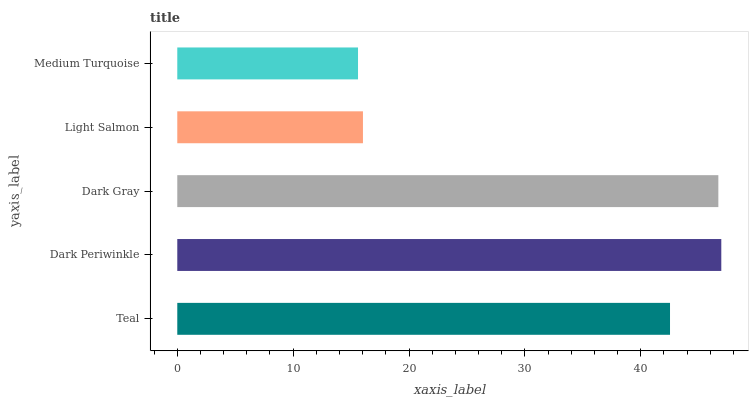Is Medium Turquoise the minimum?
Answer yes or no. Yes. Is Dark Periwinkle the maximum?
Answer yes or no. Yes. Is Dark Gray the minimum?
Answer yes or no. No. Is Dark Gray the maximum?
Answer yes or no. No. Is Dark Periwinkle greater than Dark Gray?
Answer yes or no. Yes. Is Dark Gray less than Dark Periwinkle?
Answer yes or no. Yes. Is Dark Gray greater than Dark Periwinkle?
Answer yes or no. No. Is Dark Periwinkle less than Dark Gray?
Answer yes or no. No. Is Teal the high median?
Answer yes or no. Yes. Is Teal the low median?
Answer yes or no. Yes. Is Light Salmon the high median?
Answer yes or no. No. Is Dark Gray the low median?
Answer yes or no. No. 